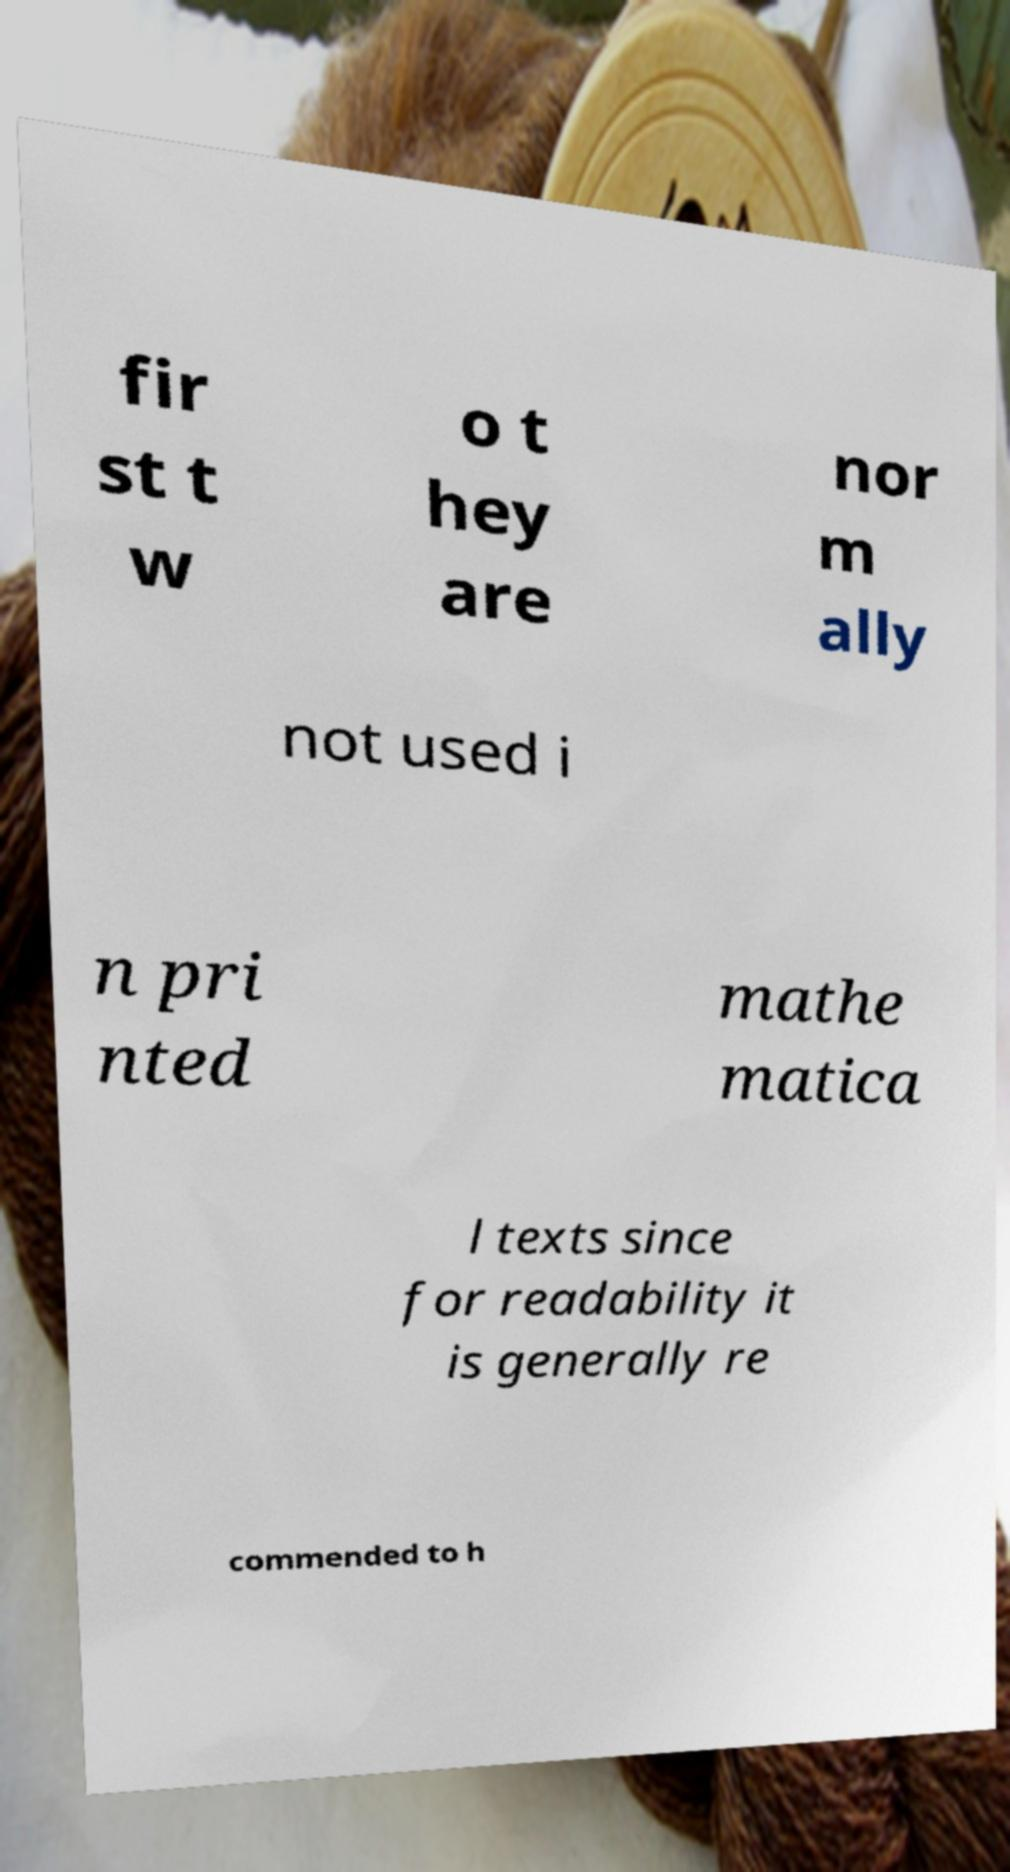What messages or text are displayed in this image? I need them in a readable, typed format. fir st t w o t hey are nor m ally not used i n pri nted mathe matica l texts since for readability it is generally re commended to h 